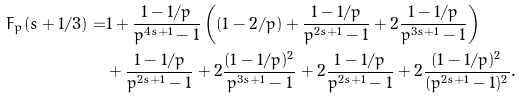<formula> <loc_0><loc_0><loc_500><loc_500>F _ { p } ( s + 1 / 3 ) = & 1 + \frac { 1 - 1 / p } { p ^ { 4 s + 1 } - 1 } \left ( ( 1 - 2 / p ) + \frac { 1 - 1 / p } { p ^ { 2 s + 1 } - 1 } + 2 \frac { 1 - 1 / p } { p ^ { 3 s + 1 } - 1 } \right ) \\ & + \frac { 1 - 1 / p } { p ^ { 2 s + 1 } - 1 } + 2 \frac { ( 1 - 1 / p ) ^ { 2 } } { p ^ { 3 s + 1 } - 1 } + 2 \frac { 1 - 1 / p } { p ^ { 2 s + 1 } - 1 } + 2 \frac { ( 1 - 1 / p ) ^ { 2 } } { ( p ^ { 2 s + 1 } - 1 ) ^ { 2 } } .</formula> 